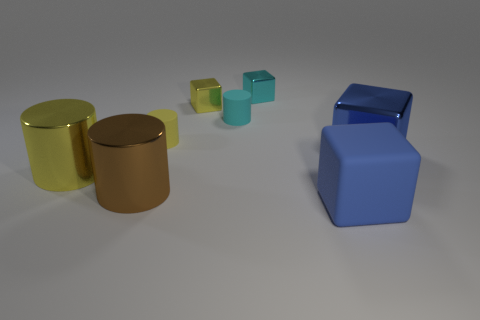Add 1 tiny things. How many objects exist? 9 Add 2 brown cylinders. How many brown cylinders are left? 3 Add 3 small cyan cubes. How many small cyan cubes exist? 4 Subtract 0 green cubes. How many objects are left? 8 Subtract all shiny cubes. Subtract all big blue metal objects. How many objects are left? 4 